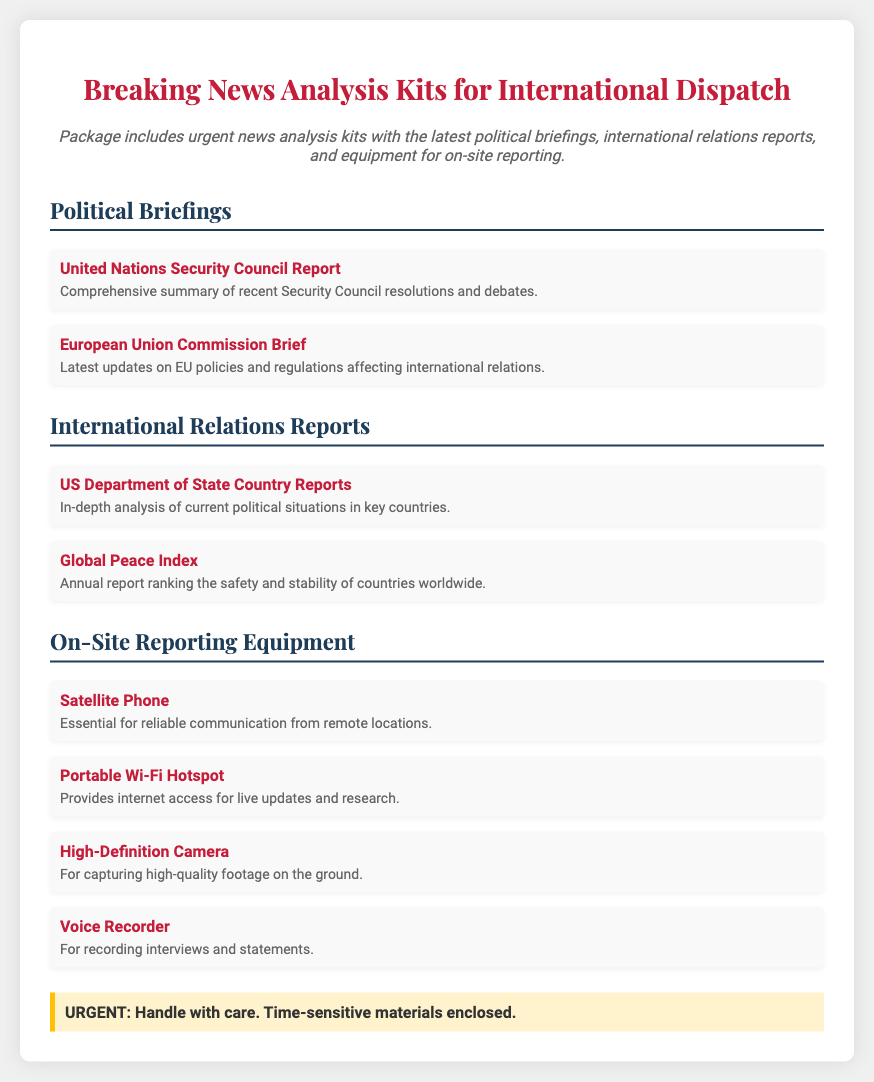what is included in the package? The package includes urgent news analysis kits with the latest political briefings, international relations reports, and equipment for on-site reporting.
Answer: urgent news analysis kits how many political briefings are listed? There are two political briefings listed in the document.
Answer: 2 name one item of on-site reporting equipment. The document lists several items, including a satellite phone.
Answer: Satellite Phone what type of report is the Global Peace Index? The Global Peace Index is an annual report that ranks the safety and stability of countries worldwide.
Answer: annual report what is the urgency status indicated in the document? The document highlights that it is crucial to handle the package with care and that time-sensitive materials are enclosed.
Answer: URGENT 